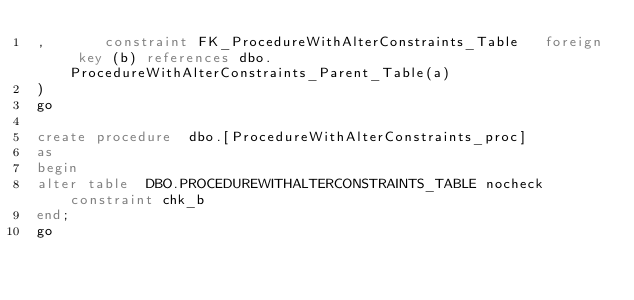Convert code to text. <code><loc_0><loc_0><loc_500><loc_500><_SQL_>,       constraint FK_ProcedureWithAlterConstraints_Table   foreign key (b) references dbo.ProcedureWithAlterConstraints_Parent_Table(a)
)
go

create procedure  dbo.[ProcedureWithAlterConstraints_proc]
as
begin
alter table  DBO.PROCEDUREWITHALTERCONSTRAINTS_TABLE nocheck constraint chk_b
end;
go</code> 